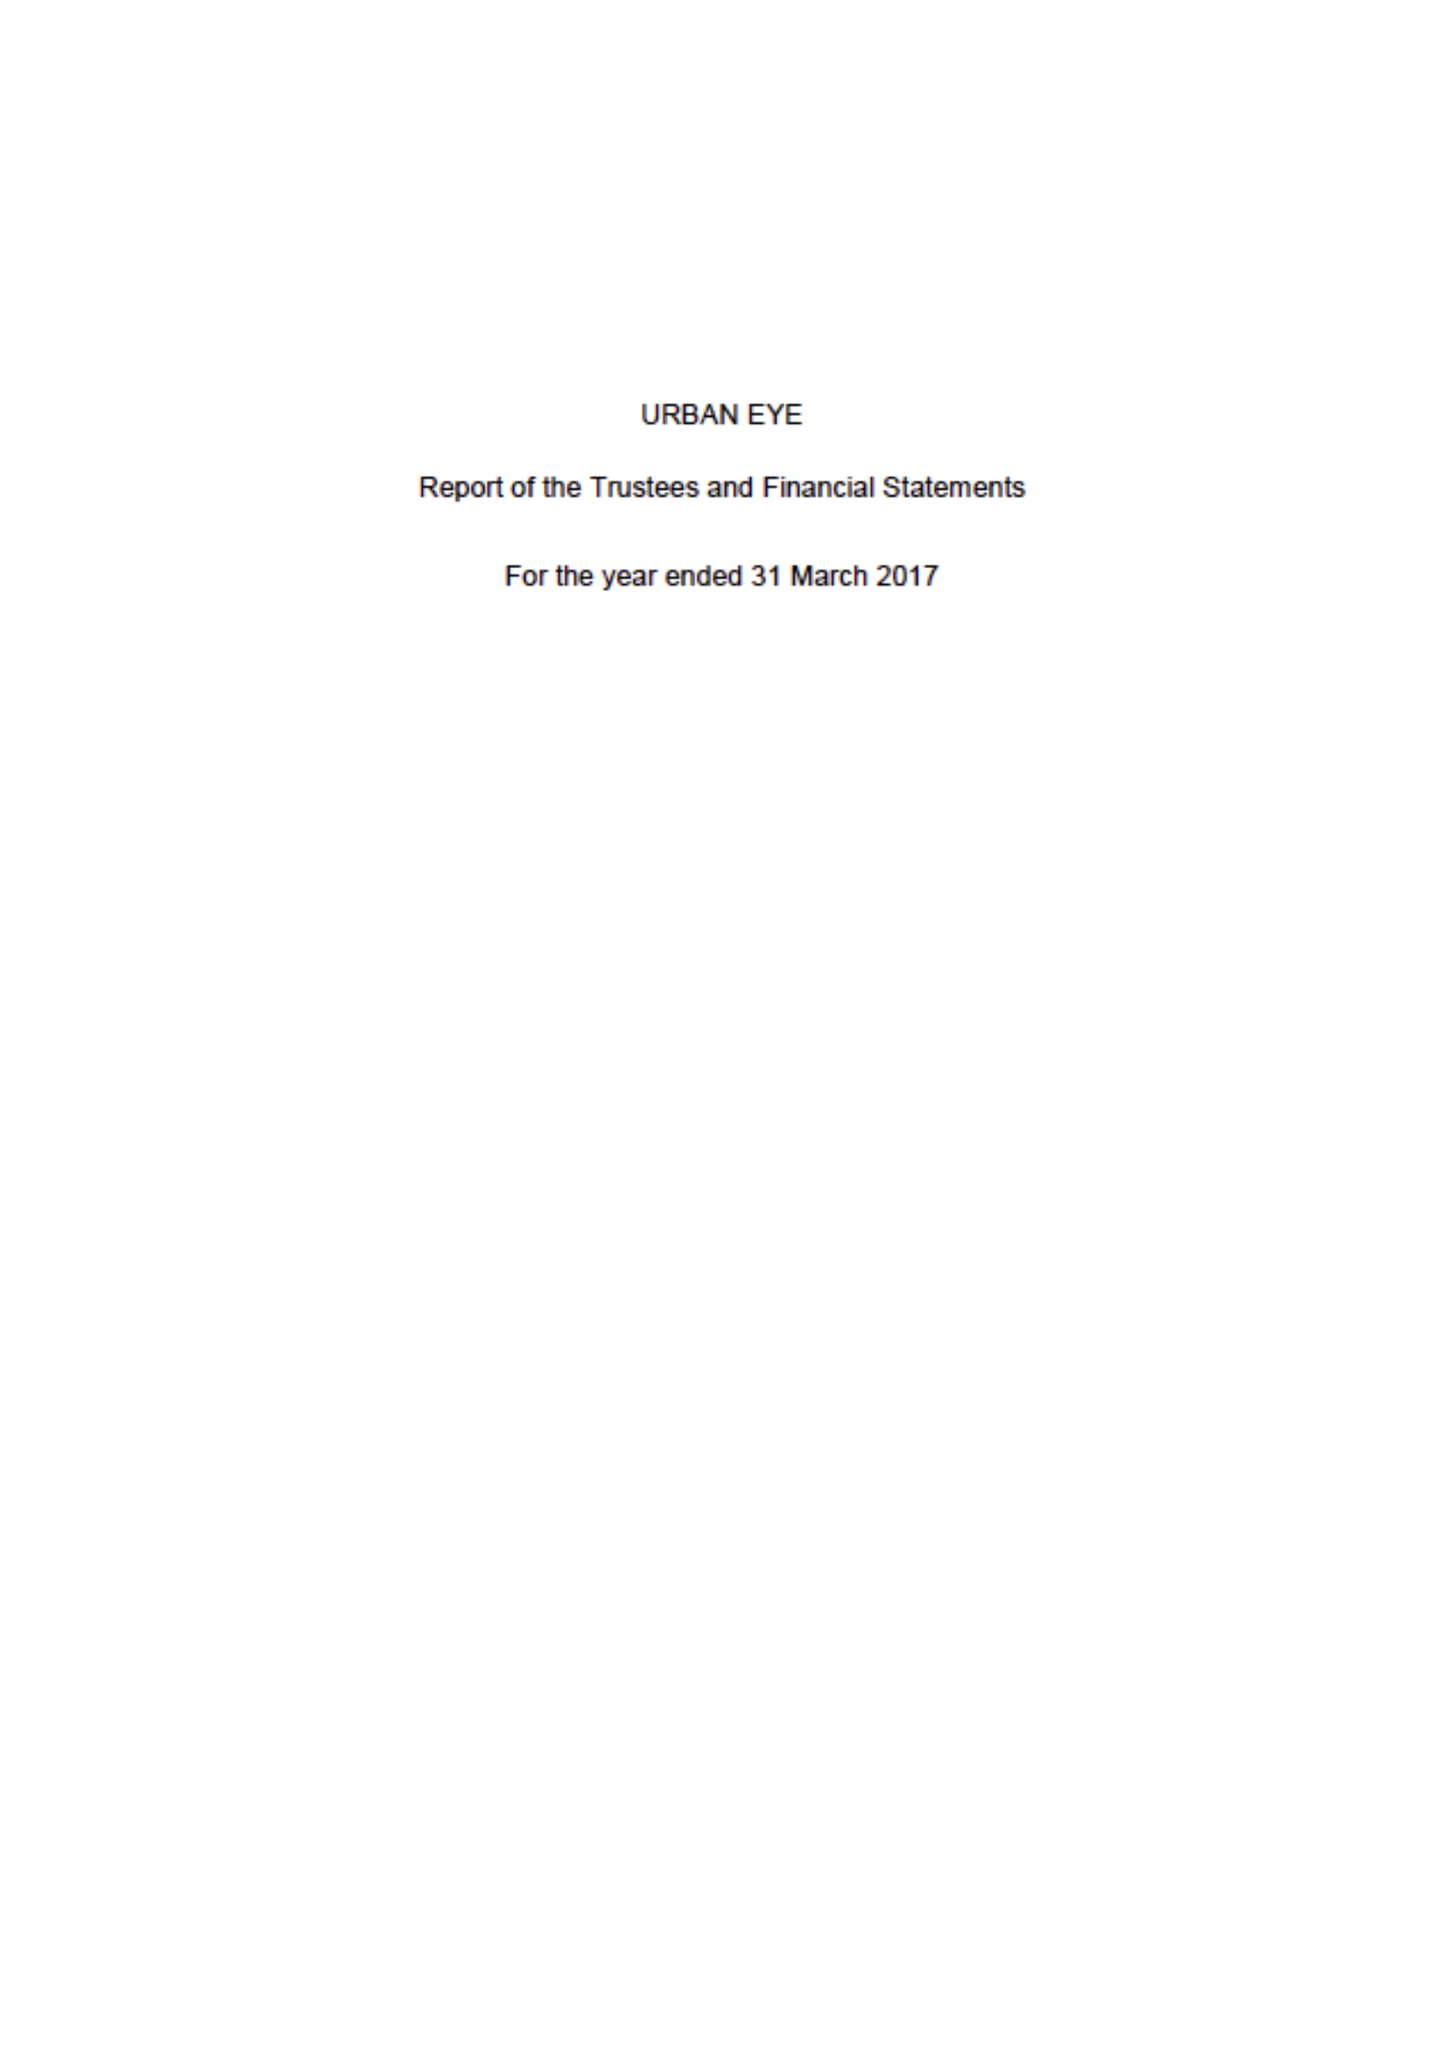What is the value for the address__post_town?
Answer the question using a single word or phrase. LONDON 